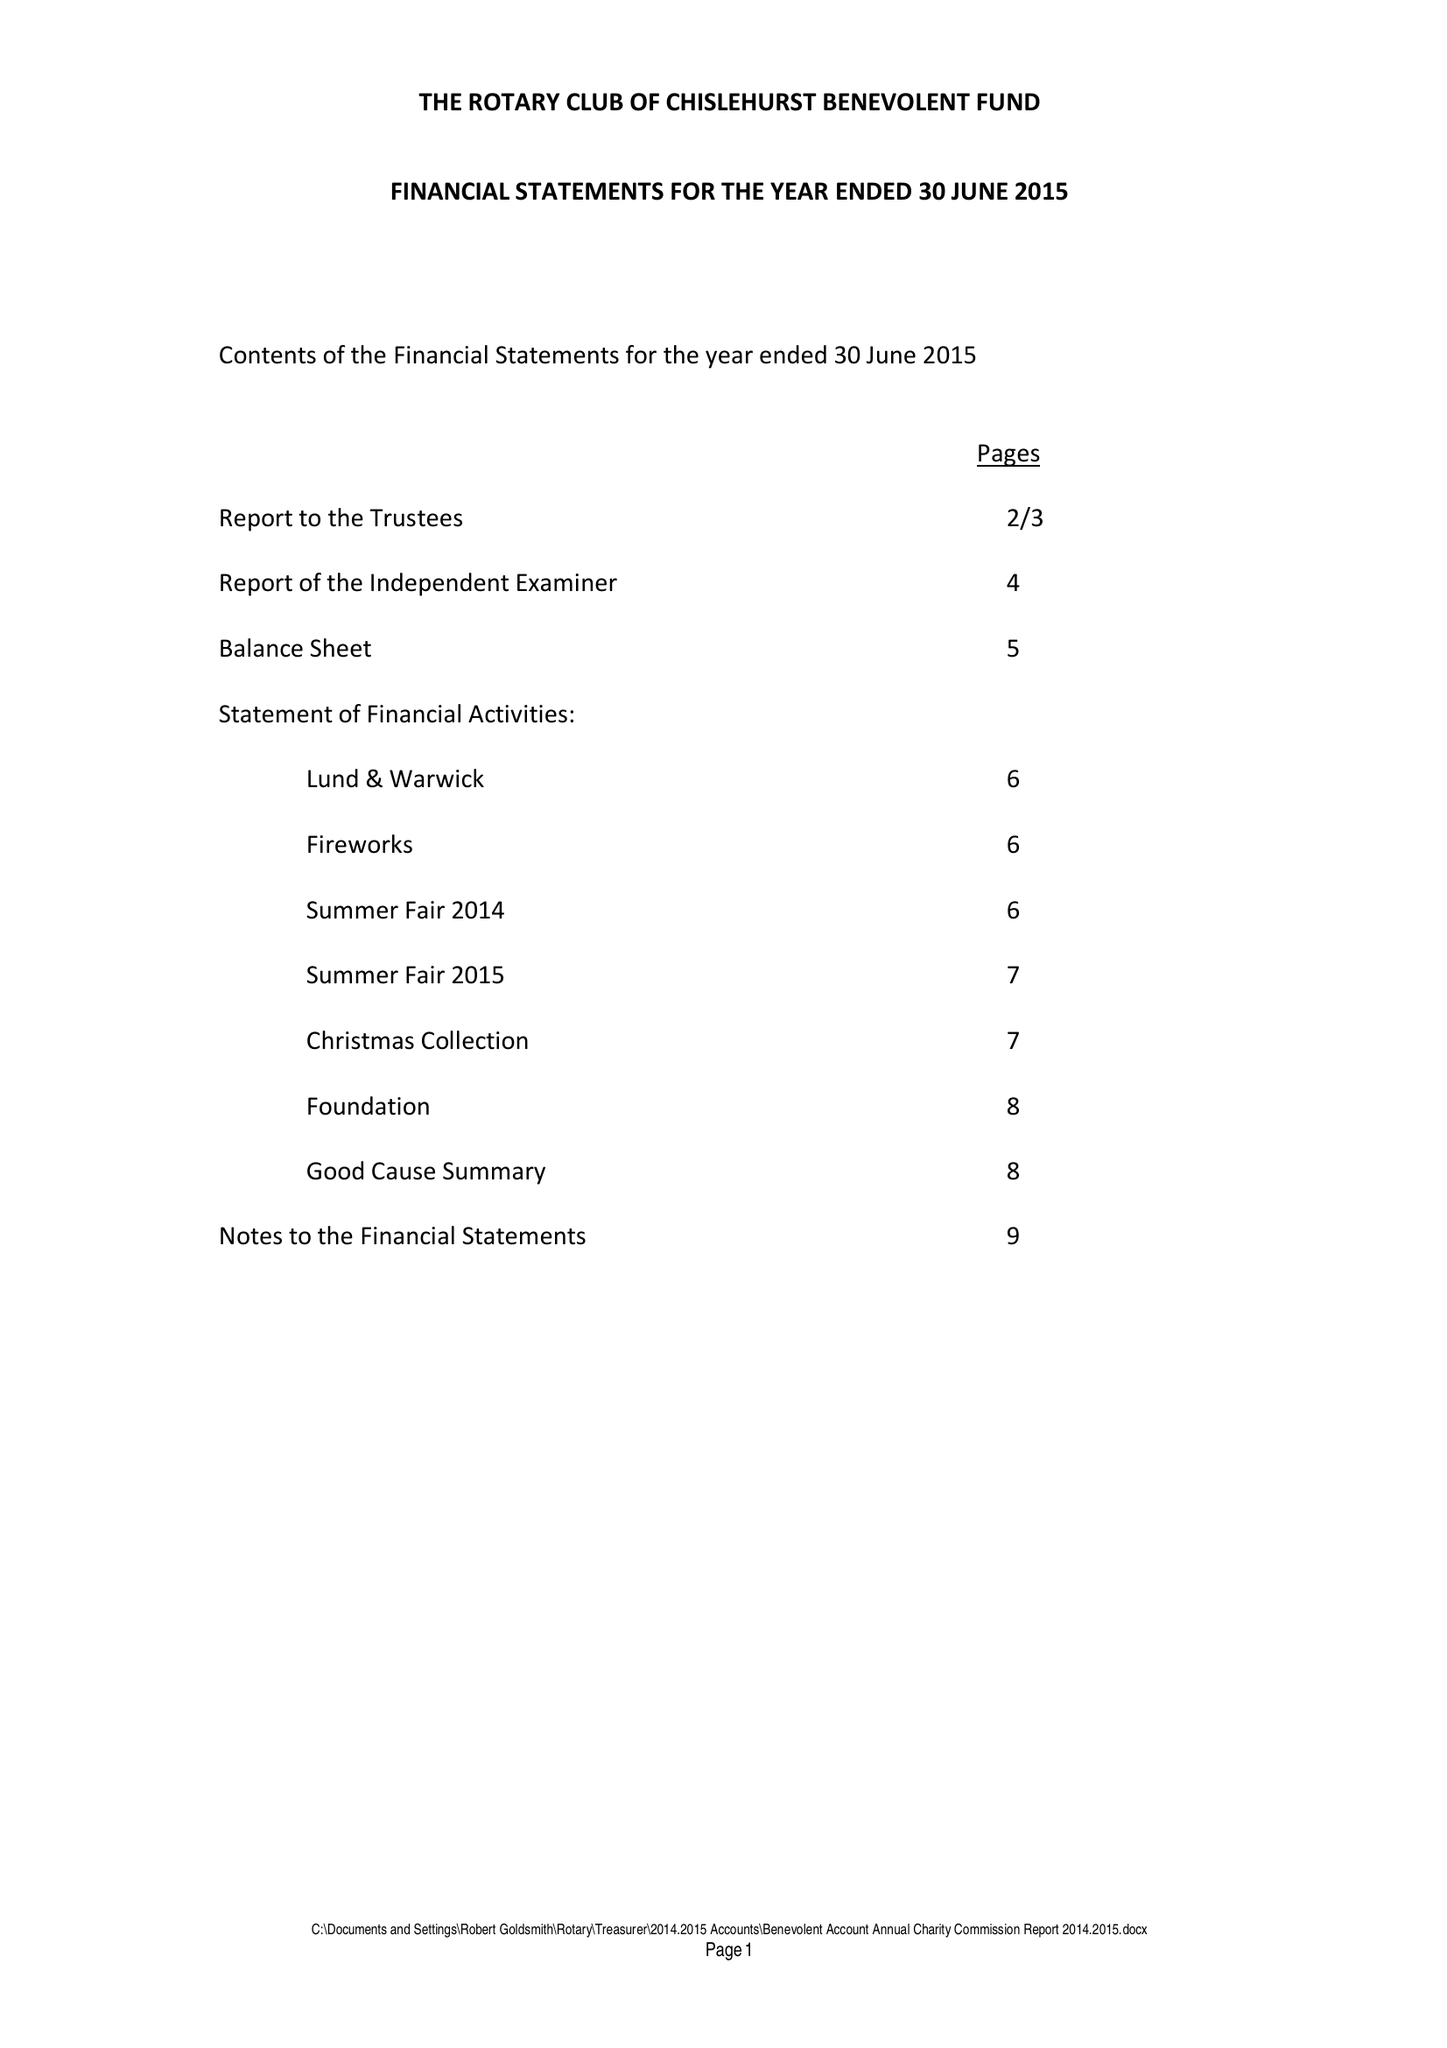What is the value for the income_annually_in_british_pounds?
Answer the question using a single word or phrase. 42447.00 